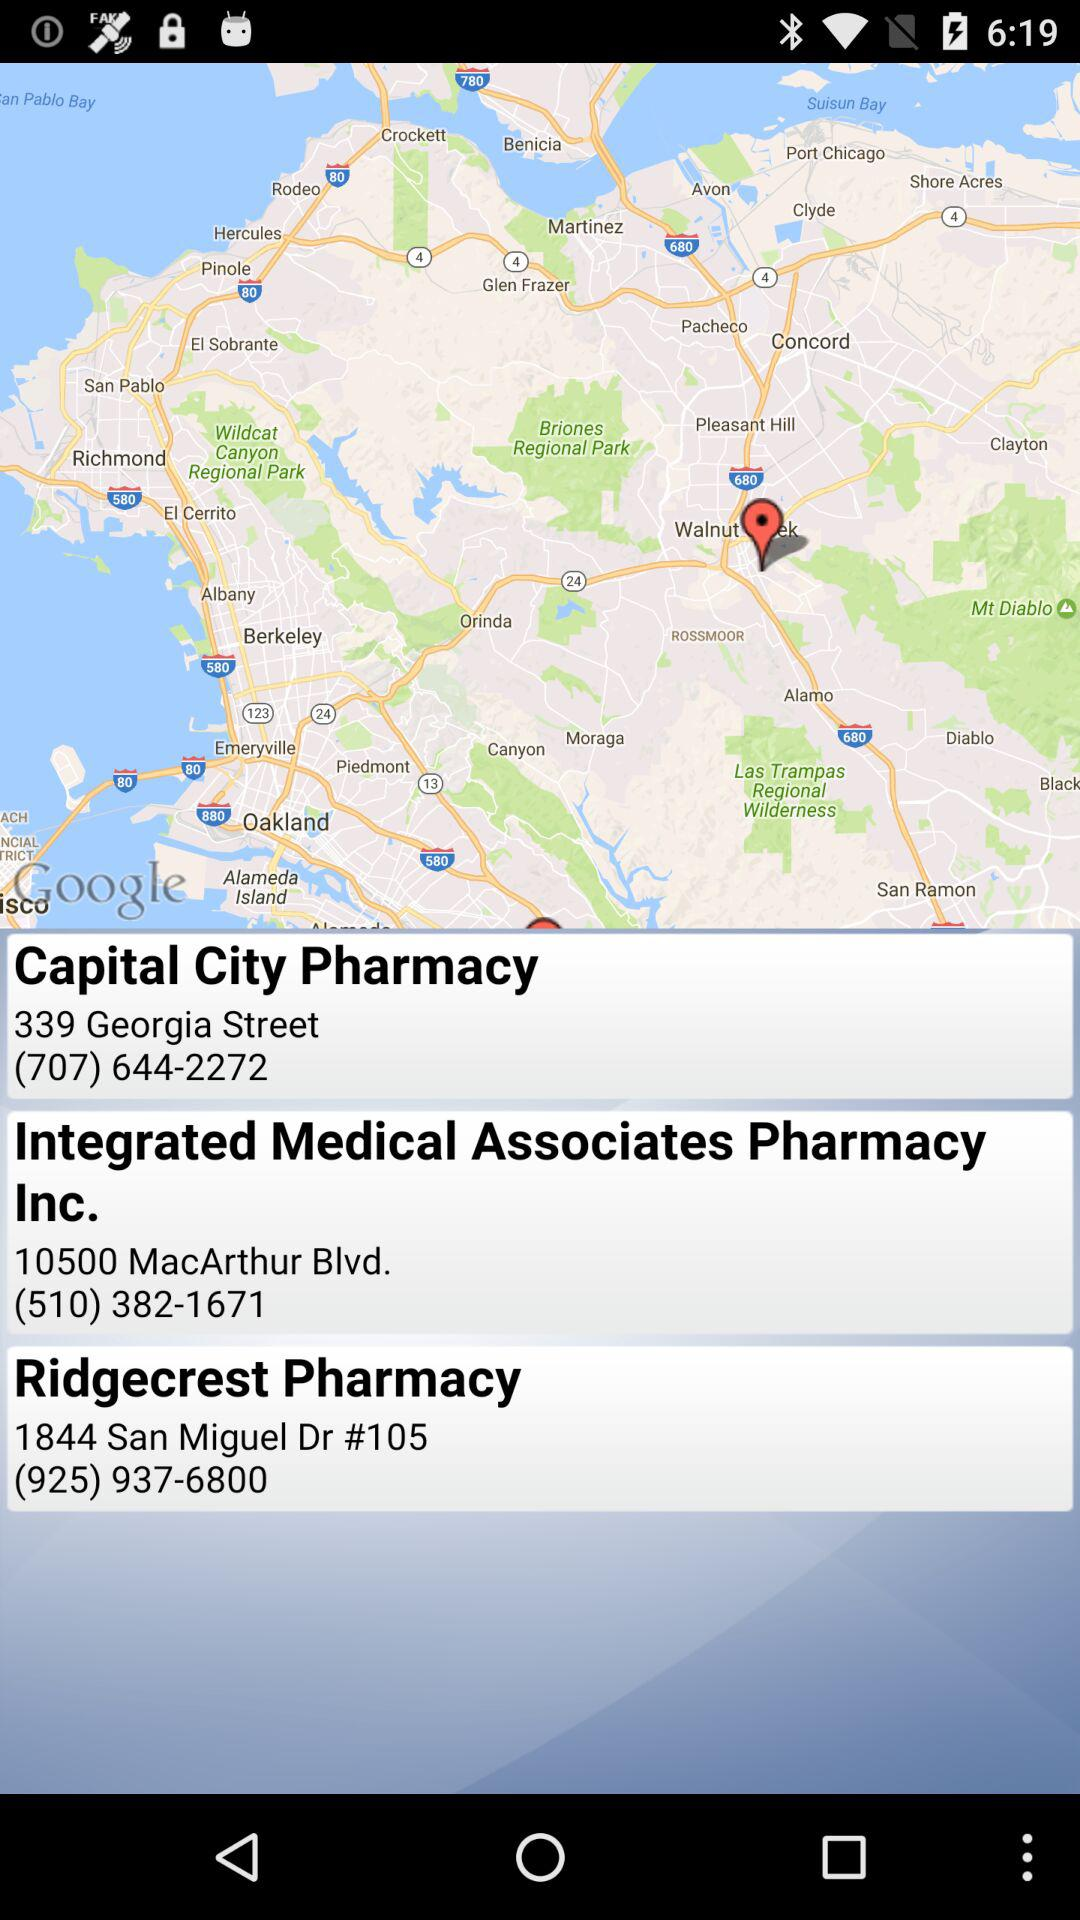Which pharmacy is located at the 10500 MacArthur Blvd location? The pharmacy is "Integrated Medical Associates Pharmacy Inc". 